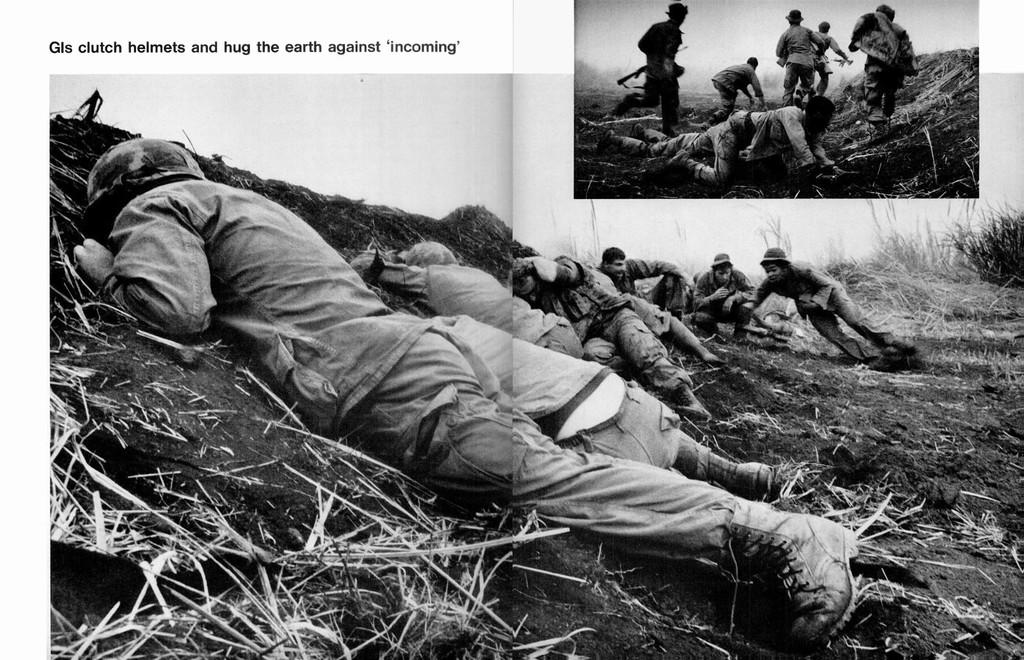What is the color scheme of the image? The image is black and white. What type of picture is it? It is a collage picture. Who can be seen in the image? There are people in the image, specifically military personnel. What is the ground like in the image? There is ground visible in the image, and it appears to have grass. Are there any plants in the image? Yes, there are plants in the image. What caption is written below the image? There is no caption visible in the image, as it is a black and white collage picture of military personnel. What channel is the image broadcasted on? The image is not a video or broadcasted on any channel; it is a still picture. 